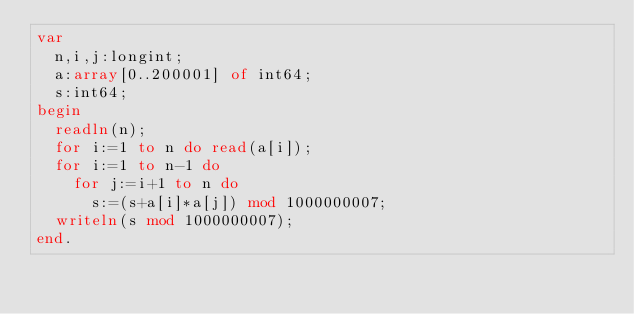Convert code to text. <code><loc_0><loc_0><loc_500><loc_500><_Pascal_>var
  n,i,j:longint;
  a:array[0..200001] of int64;
  s:int64;
begin
  readln(n);
  for i:=1 to n do read(a[i]);
  for i:=1 to n-1 do
    for j:=i+1 to n do
      s:=(s+a[i]*a[j]) mod 1000000007;
  writeln(s mod 1000000007);
end.</code> 